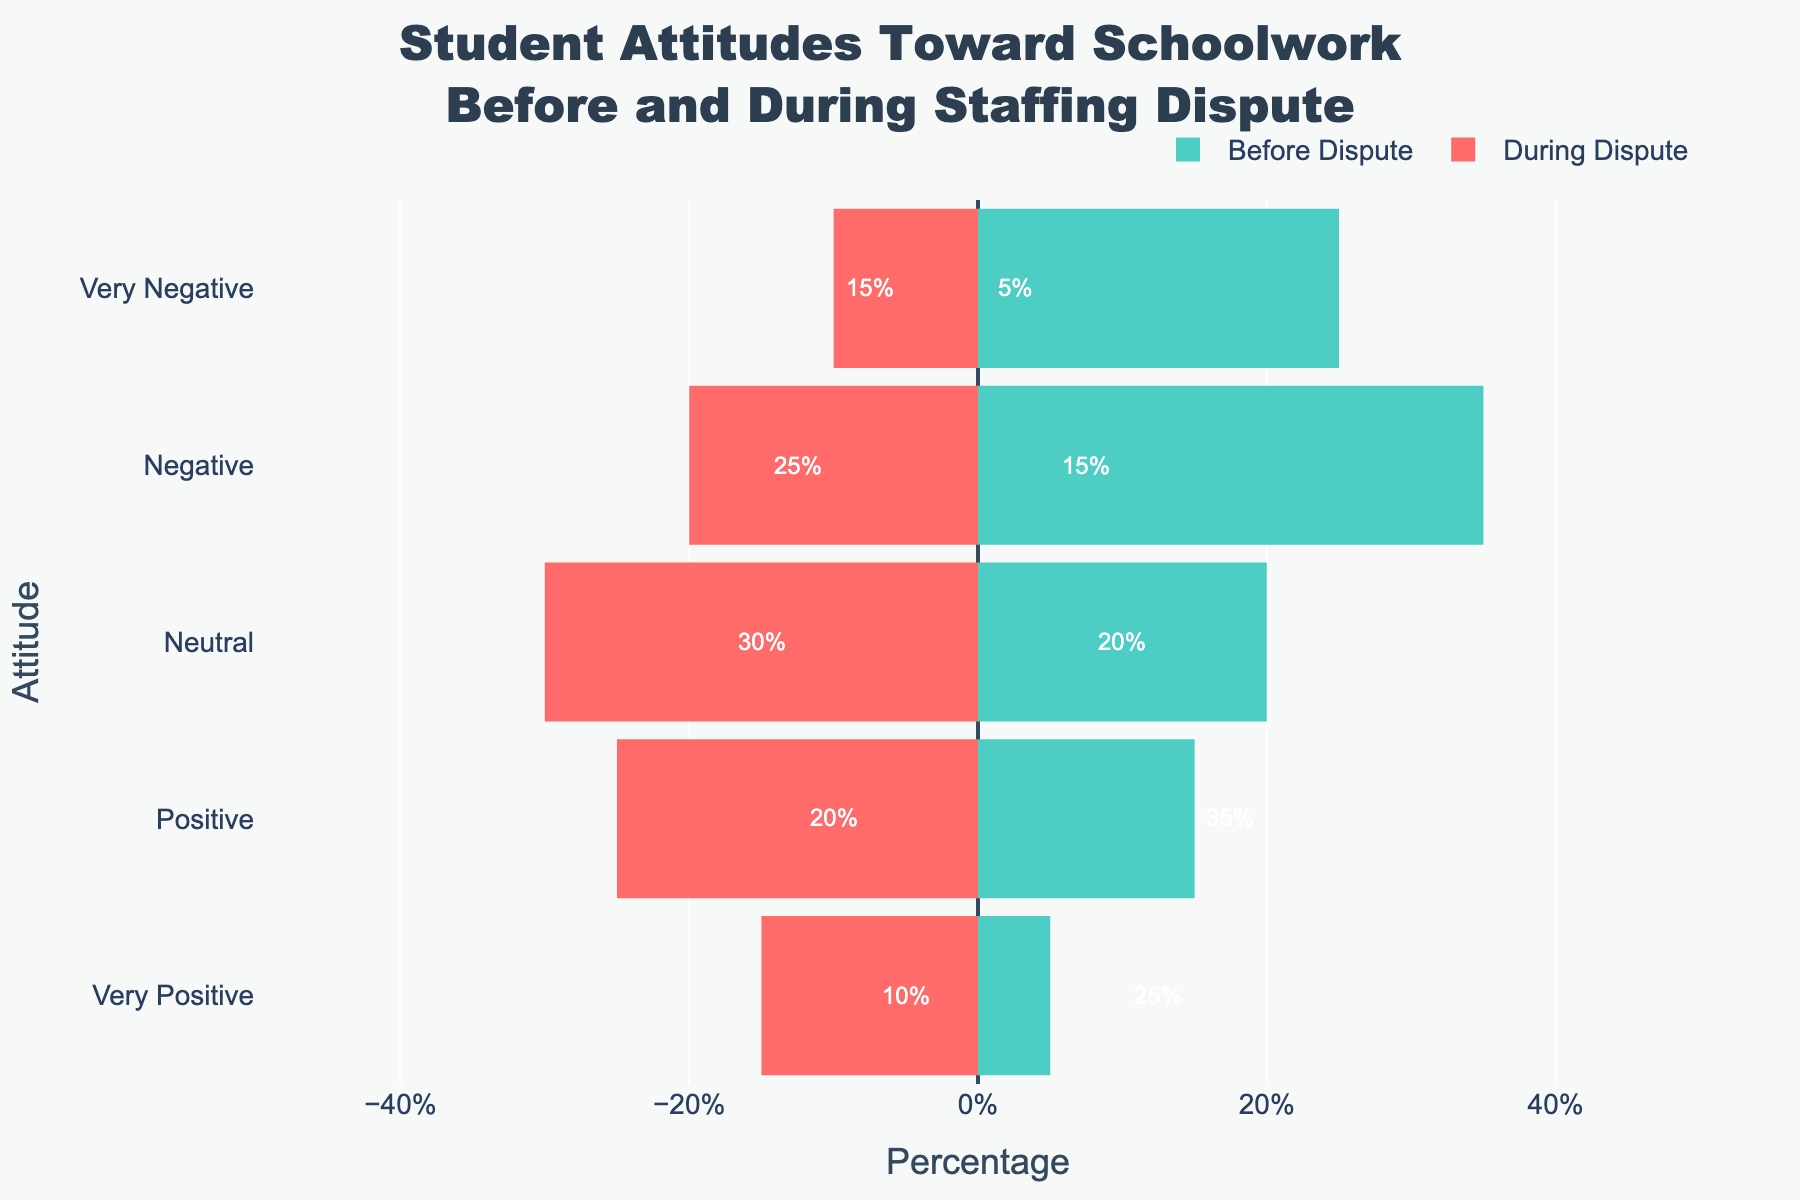What difference in percentage is observed in 'Very Positive' attitudes before and during the dispute? To find the difference, look at the 'Very Positive' percentage for both categories. Subtract the 'During Dispute' value from the 'Before Dispute': 25% - 10% = 15%.
Answer: 15% Which attitude category saw the highest increase during the dispute? Identify which attitude categories show an increase when comparing 'Before Dispute' and 'During Dispute'. Only 'Neutral' has increased from 20% to 30%.
Answer: Neutral Which category experienced the most significant decline during the dispute? Compare the percentage changes for all categories. 'Very Positive' declined from 25% to 10%, a 15% decrease.
Answer: Very Positive What is the total percentage for Positive and Very Positive attitudes before the dispute? Add the percentages for 'Positive' and 'Very Positive' attitudes before the dispute: 35% + 25% = 60%.
Answer: 60% How much greater is the percentage of 'Negative' attitudes during the dispute compared to 'Neutral' before the dispute? Subtract the 'Neutral' percentage before the dispute from the 'Negative' percentage during the dispute: 25% - 20% = 5%.
Answer: 5% Comparing 'Very Negative' attitudes before and during the dispute, which time period had a higher percentage? Check the percentages for 'Very Negative' attitudes before (5%) and during (15%) the dispute. During the dispute is higher.
Answer: During the dispute How much of the overall attitude shifted from Positive or Very Positive to Negative or Very Negative due to the dispute? The reduction in Positive and Very Positive combined is (35% + 25% - 20% - 10%) = 30%. The increase in Negative and Very Negative combined is (25% + 15% - 15% - 5%) = 20%. Hence, 30% shifted from Positive/Very Positive to other attitudes, and a part went to Neutral.
Answer: 30% What percentage of students were Neutral before and during the dispute combined? Add the Neutral percentages for both periods: 20% + 30% = 50%.
Answer: 50% Which period saw a higher overall negative sentiment (combining Negative and Very Negative attitudes)? Add Negative and Very Negative percentages for both periods: Before (15% + 5% = 20%) and During (25% + 15% = 40%). During is higher.
Answer: During the dispute Are the lengths of the bars in the 'During Dispute' category primarily shifted to the left or the right? Bars for 'During Dispute' are shown with negative values for better visual differentiation, meaning they are shifted to the left.
Answer: Left 